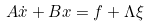<formula> <loc_0><loc_0><loc_500><loc_500>A \dot { x } + B x = f + \Lambda \xi</formula> 